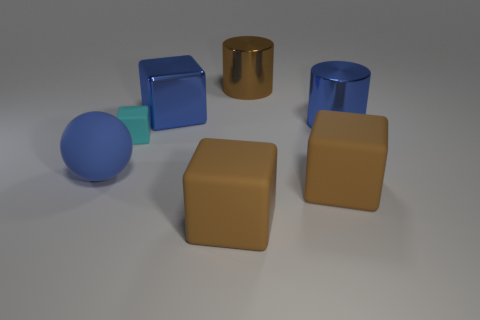Are there an equal number of large rubber balls that are behind the blue block and tiny purple balls?
Ensure brevity in your answer.  Yes. Is there anything else that is the same size as the cyan object?
Your answer should be compact. No. The large cylinder that is in front of the brown object that is behind the big sphere is made of what material?
Keep it short and to the point. Metal. There is a object that is both in front of the cyan matte thing and to the left of the metal cube; what shape is it?
Provide a short and direct response. Sphere. There is another metallic thing that is the same shape as the cyan thing; what size is it?
Give a very brief answer. Large. Is the number of brown metallic things behind the sphere less than the number of yellow shiny balls?
Make the answer very short. No. What size is the rubber cube behind the big blue matte sphere?
Your response must be concise. Small. What number of big shiny objects are the same color as the big sphere?
Offer a terse response. 2. Is there any other thing that has the same shape as the blue matte thing?
Offer a terse response. No. There is a blue thing in front of the cylinder in front of the metal cube; is there a brown thing that is on the left side of it?
Your answer should be very brief. No. 